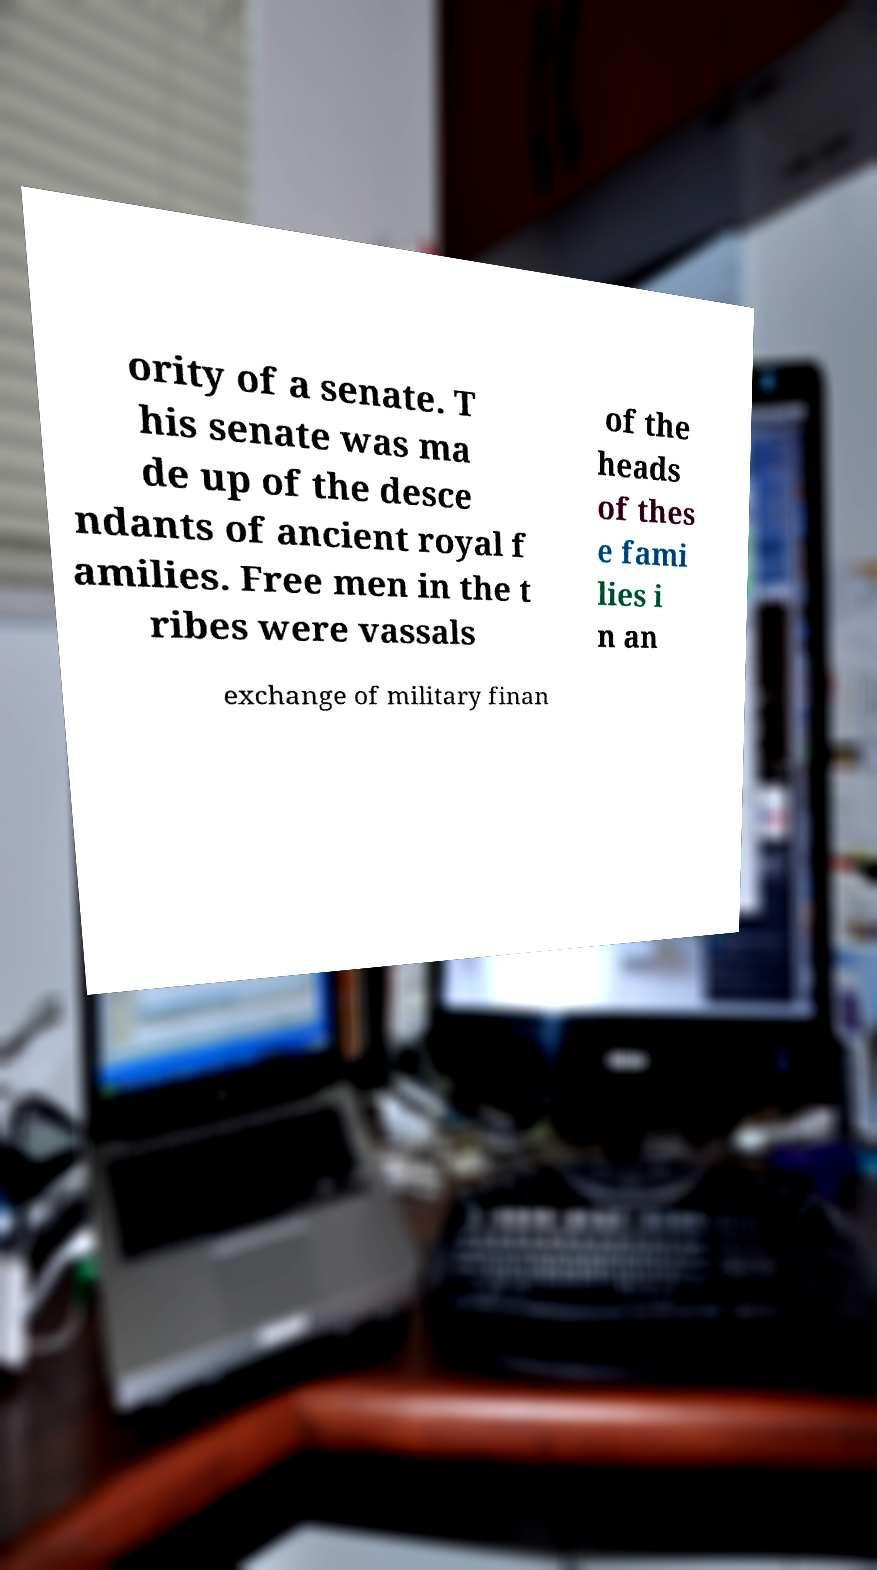There's text embedded in this image that I need extracted. Can you transcribe it verbatim? ority of a senate. T his senate was ma de up of the desce ndants of ancient royal f amilies. Free men in the t ribes were vassals of the heads of thes e fami lies i n an exchange of military finan 